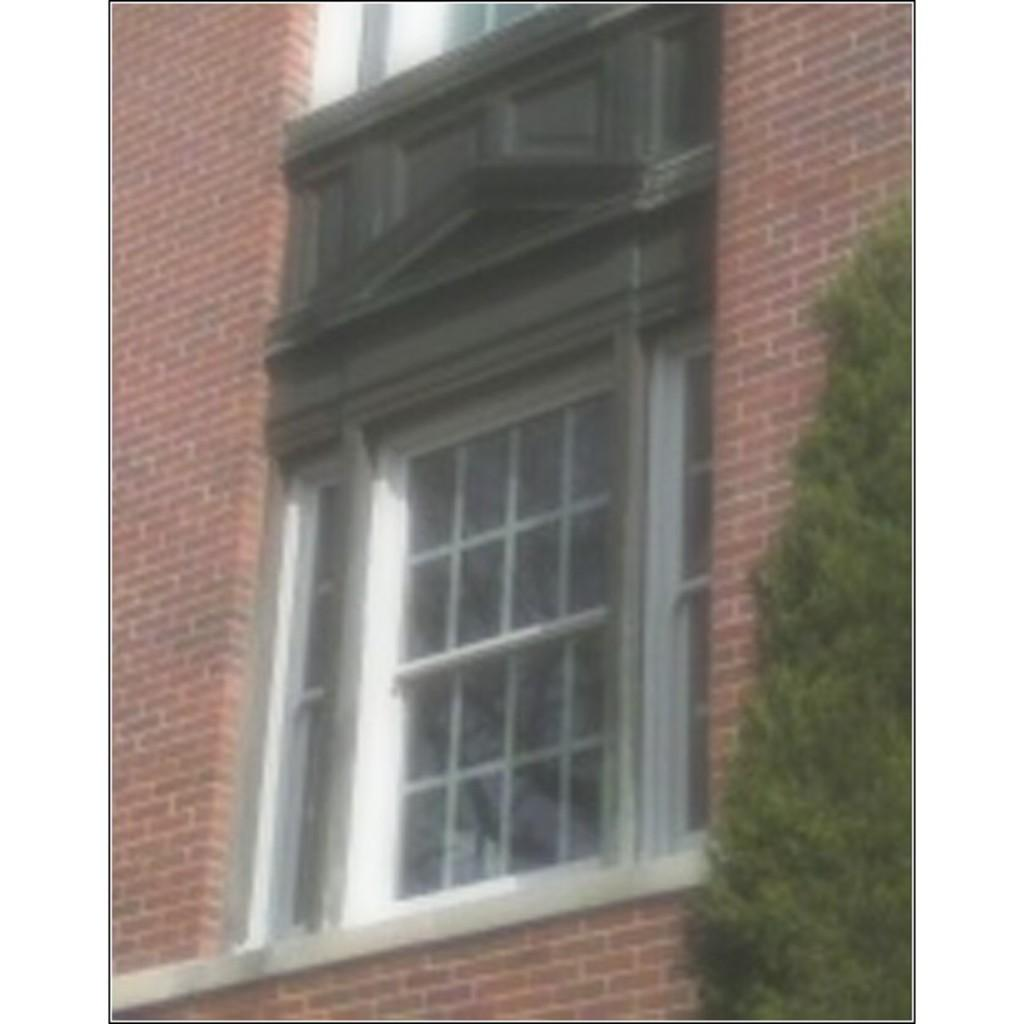What type of wall is visible in the image? There is a brick wall in the image. What material is used for the window in the image? There is a glass window in the image. What can be seen on the right side of the image? There is a tree on the right side of the image. What letters are written on the canvas in the image? There is no canvas present in the image, and therefore no letters can be found on it. What type of vessel is visible in the image? There is no vessel present in the image. 